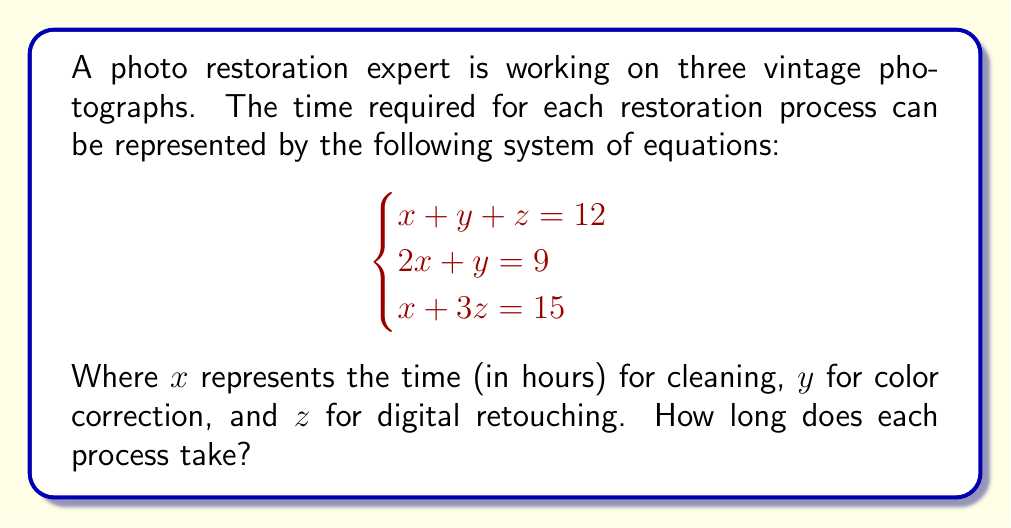Can you answer this question? Let's solve this system of equations step by step:

1) From the second equation: $2x + y = 9$
   Rearrange to isolate $y$: $y = 9 - 2x$

2) Substitute this into the first equation:
   $x + (9 - 2x) + z = 12$
   Simplify: $x - 2x + z = 12 - 9$
   $-x + z = 3$ ... (Equation A)

3) From the third equation: $x + 3z = 15$
   Rearrange: $x = 15 - 3z$ ... (Equation B)

4) Substitute Equation B into Equation A:
   $-(15 - 3z) + z = 3$
   $-15 + 3z + z = 3$
   $4z = 18$
   $z = 4.5$

5) Substitute $z = 4.5$ into Equation B:
   $x = 15 - 3(4.5) = 15 - 13.5 = 1.5$

6) Substitute $x = 1.5$ into the second original equation:
   $2(1.5) + y = 9$
   $3 + y = 9$
   $y = 6$

Therefore, $x = 1.5$, $y = 6$, and $z = 4.5$.
Answer: Cleaning: 1.5 hours, Color correction: 6 hours, Digital retouching: 4.5 hours 